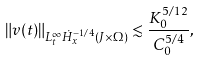Convert formula to latex. <formula><loc_0><loc_0><loc_500><loc_500>\| v ( t ) \| _ { L _ { t } ^ { \infty } \dot { H } _ { x } ^ { - 1 / 4 } ( J \times \Omega ) } \lesssim \frac { K _ { 0 } ^ { 5 / 1 2 } } { C _ { 0 } ^ { 5 / 4 } } ,</formula> 